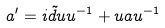<formula> <loc_0><loc_0><loc_500><loc_500>a ^ { \prime } = i \tilde { d } u u ^ { - 1 } + u a u ^ { - 1 }</formula> 